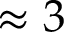Convert formula to latex. <formula><loc_0><loc_0><loc_500><loc_500>\approx 3</formula> 